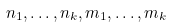Convert formula to latex. <formula><loc_0><loc_0><loc_500><loc_500>n _ { 1 } , \dots , n _ { k } , m _ { 1 } , \dots , m _ { k }</formula> 